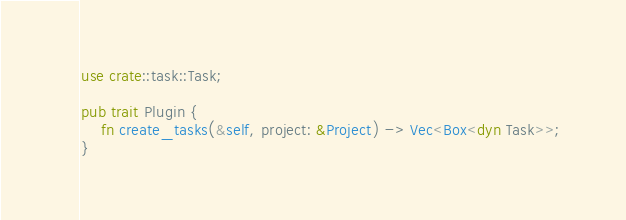<code> <loc_0><loc_0><loc_500><loc_500><_Rust_>use crate::task::Task;

pub trait Plugin {
    fn create_tasks(&self, project: &Project) -> Vec<Box<dyn Task>>;
}
</code> 